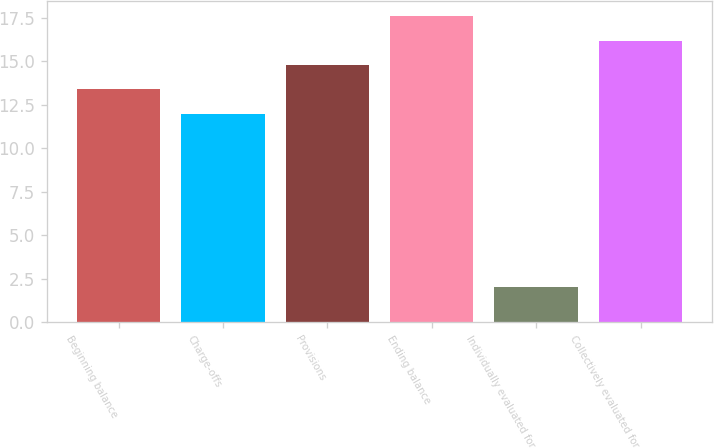Convert chart to OTSL. <chart><loc_0><loc_0><loc_500><loc_500><bar_chart><fcel>Beginning balance<fcel>Charge-offs<fcel>Provisions<fcel>Ending balance<fcel>Individually evaluated for<fcel>Collectively evaluated for<nl><fcel>13.4<fcel>12<fcel>14.8<fcel>17.6<fcel>2<fcel>16.2<nl></chart> 